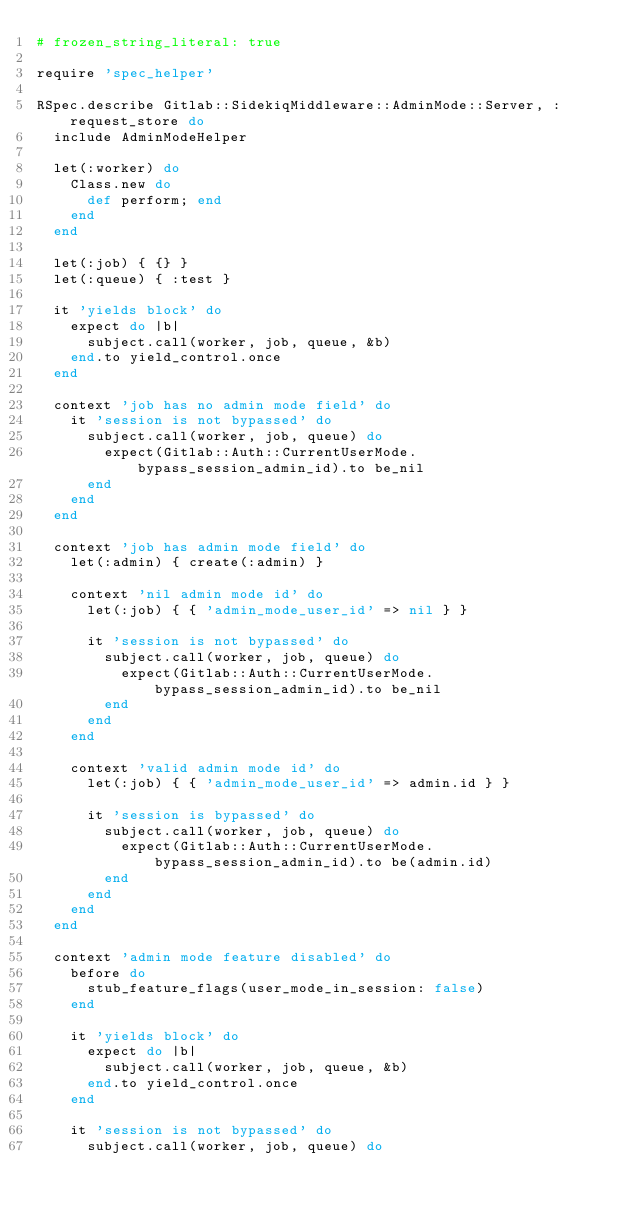<code> <loc_0><loc_0><loc_500><loc_500><_Ruby_># frozen_string_literal: true

require 'spec_helper'

RSpec.describe Gitlab::SidekiqMiddleware::AdminMode::Server, :request_store do
  include AdminModeHelper

  let(:worker) do
    Class.new do
      def perform; end
    end
  end

  let(:job) { {} }
  let(:queue) { :test }

  it 'yields block' do
    expect do |b|
      subject.call(worker, job, queue, &b)
    end.to yield_control.once
  end

  context 'job has no admin mode field' do
    it 'session is not bypassed' do
      subject.call(worker, job, queue) do
        expect(Gitlab::Auth::CurrentUserMode.bypass_session_admin_id).to be_nil
      end
    end
  end

  context 'job has admin mode field' do
    let(:admin) { create(:admin) }

    context 'nil admin mode id' do
      let(:job) { { 'admin_mode_user_id' => nil } }

      it 'session is not bypassed' do
        subject.call(worker, job, queue) do
          expect(Gitlab::Auth::CurrentUserMode.bypass_session_admin_id).to be_nil
        end
      end
    end

    context 'valid admin mode id' do
      let(:job) { { 'admin_mode_user_id' => admin.id } }

      it 'session is bypassed' do
        subject.call(worker, job, queue) do
          expect(Gitlab::Auth::CurrentUserMode.bypass_session_admin_id).to be(admin.id)
        end
      end
    end
  end

  context 'admin mode feature disabled' do
    before do
      stub_feature_flags(user_mode_in_session: false)
    end

    it 'yields block' do
      expect do |b|
        subject.call(worker, job, queue, &b)
      end.to yield_control.once
    end

    it 'session is not bypassed' do
      subject.call(worker, job, queue) do</code> 